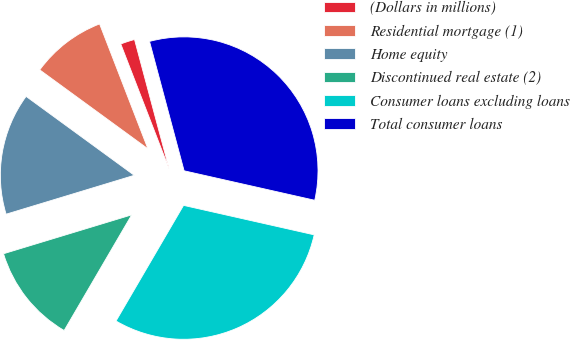Convert chart. <chart><loc_0><loc_0><loc_500><loc_500><pie_chart><fcel>(Dollars in millions)<fcel>Residential mortgage (1)<fcel>Home equity<fcel>Discontinued real estate (2)<fcel>Consumer loans excluding loans<fcel>Total consumer loans<nl><fcel>1.72%<fcel>9.09%<fcel>14.72%<fcel>11.9%<fcel>29.88%<fcel>32.69%<nl></chart> 